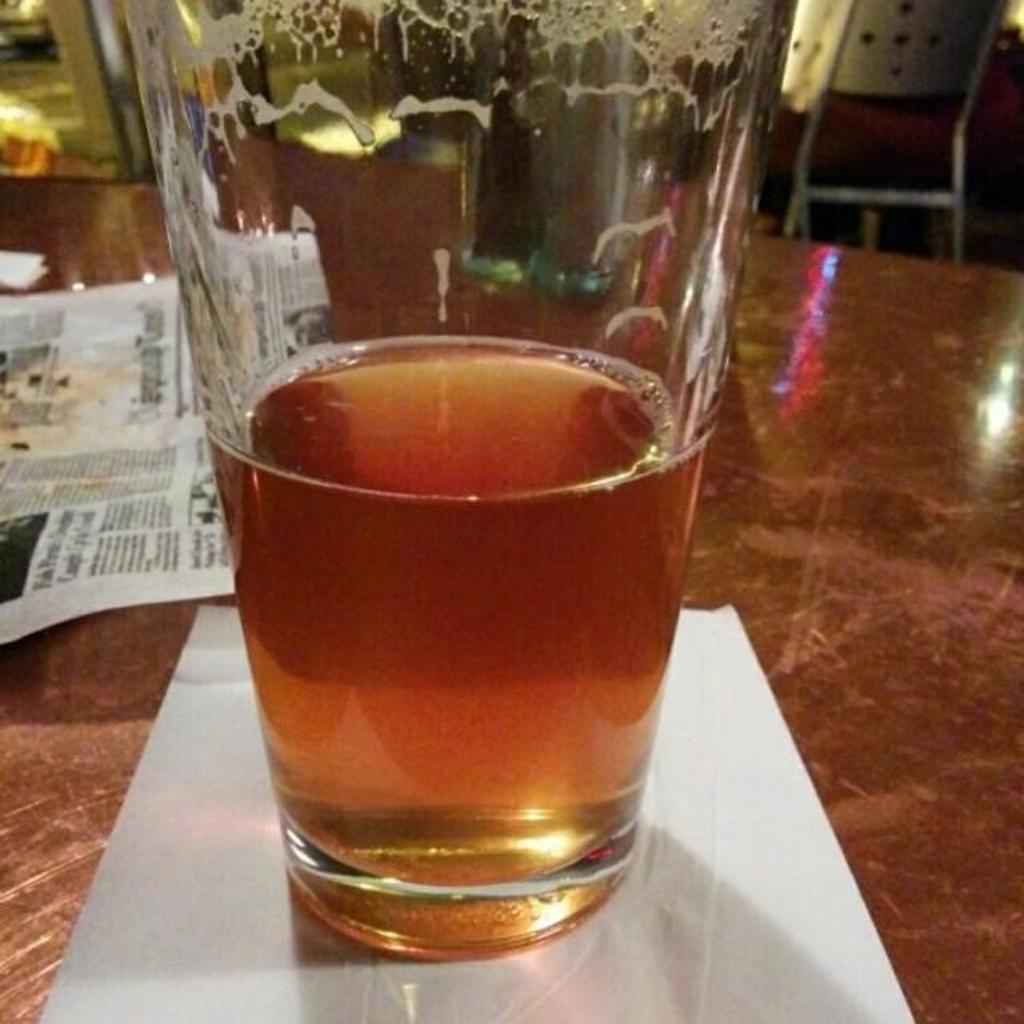What is on the table in the image? There is a glass on the table in the image. What is inside the glass? The glass has papers in it and is filled with a drink. Where is the chair located in the image? The chair is in the top right corner of the image. What role does the actor play in the image? There is no actor present in the image; it features a glass on a table with papers and a drink. 